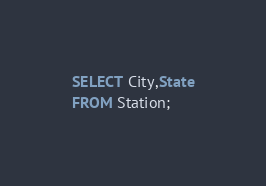Convert code to text. <code><loc_0><loc_0><loc_500><loc_500><_SQL_>SELECT City,State
FROM Station;</code> 